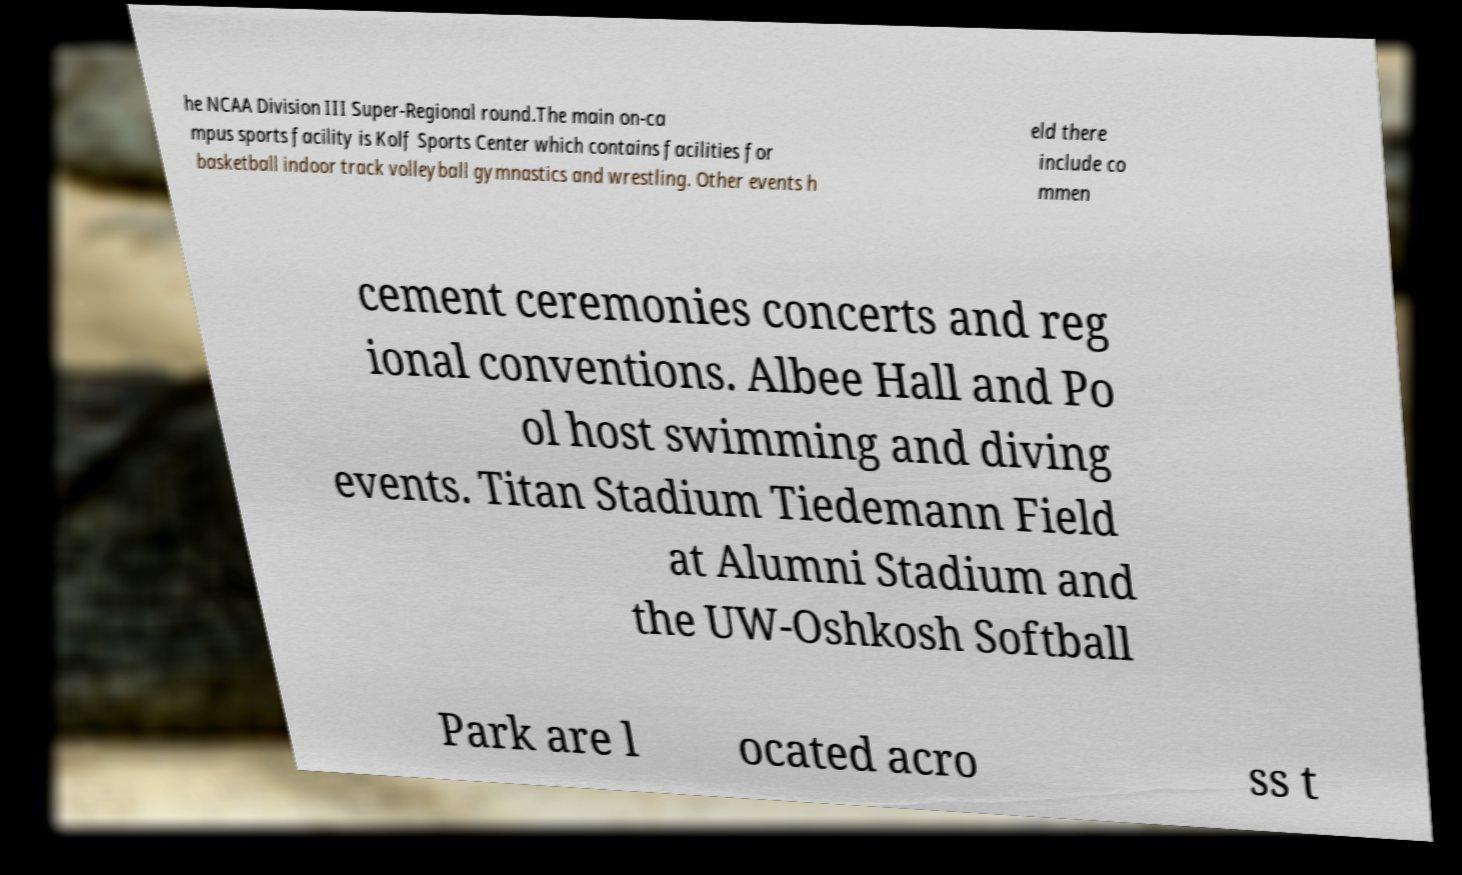Please read and relay the text visible in this image. What does it say? he NCAA Division III Super-Regional round.The main on-ca mpus sports facility is Kolf Sports Center which contains facilities for basketball indoor track volleyball gymnastics and wrestling. Other events h eld there include co mmen cement ceremonies concerts and reg ional conventions. Albee Hall and Po ol host swimming and diving events. Titan Stadium Tiedemann Field at Alumni Stadium and the UW-Oshkosh Softball Park are l ocated acro ss t 